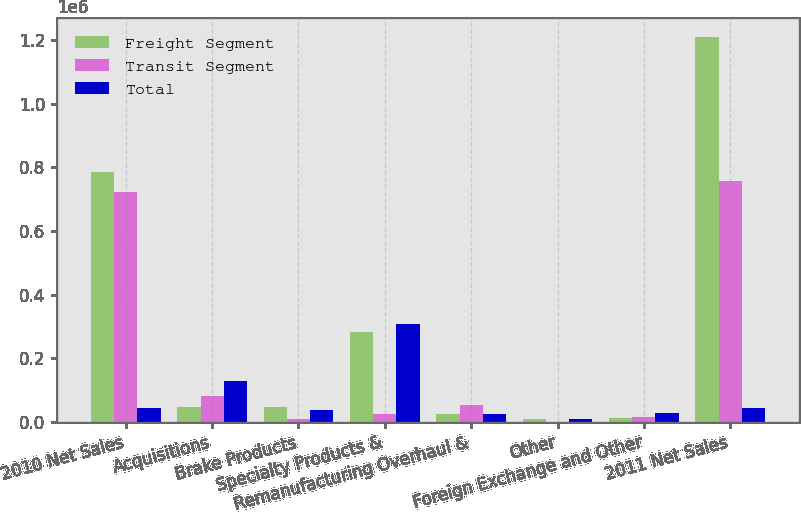Convert chart. <chart><loc_0><loc_0><loc_500><loc_500><stacked_bar_chart><ecel><fcel>2010 Net Sales<fcel>Acquisitions<fcel>Brake Products<fcel>Specialty Products &<fcel>Remanufacturing Overhaul &<fcel>Other<fcel>Foreign Exchange and Other<fcel>2011 Net Sales<nl><fcel>Freight Segment<fcel>784504<fcel>47614<fcel>47726<fcel>281487<fcel>26606<fcel>8824<fcel>13298<fcel>1.21006e+06<nl><fcel>Transit Segment<fcel>722508<fcel>80699<fcel>8424<fcel>25149<fcel>52701<fcel>302<fcel>16305<fcel>757578<nl><fcel>Total<fcel>43458<fcel>128313<fcel>39302<fcel>306636<fcel>26095<fcel>9126<fcel>29603<fcel>43458<nl></chart> 